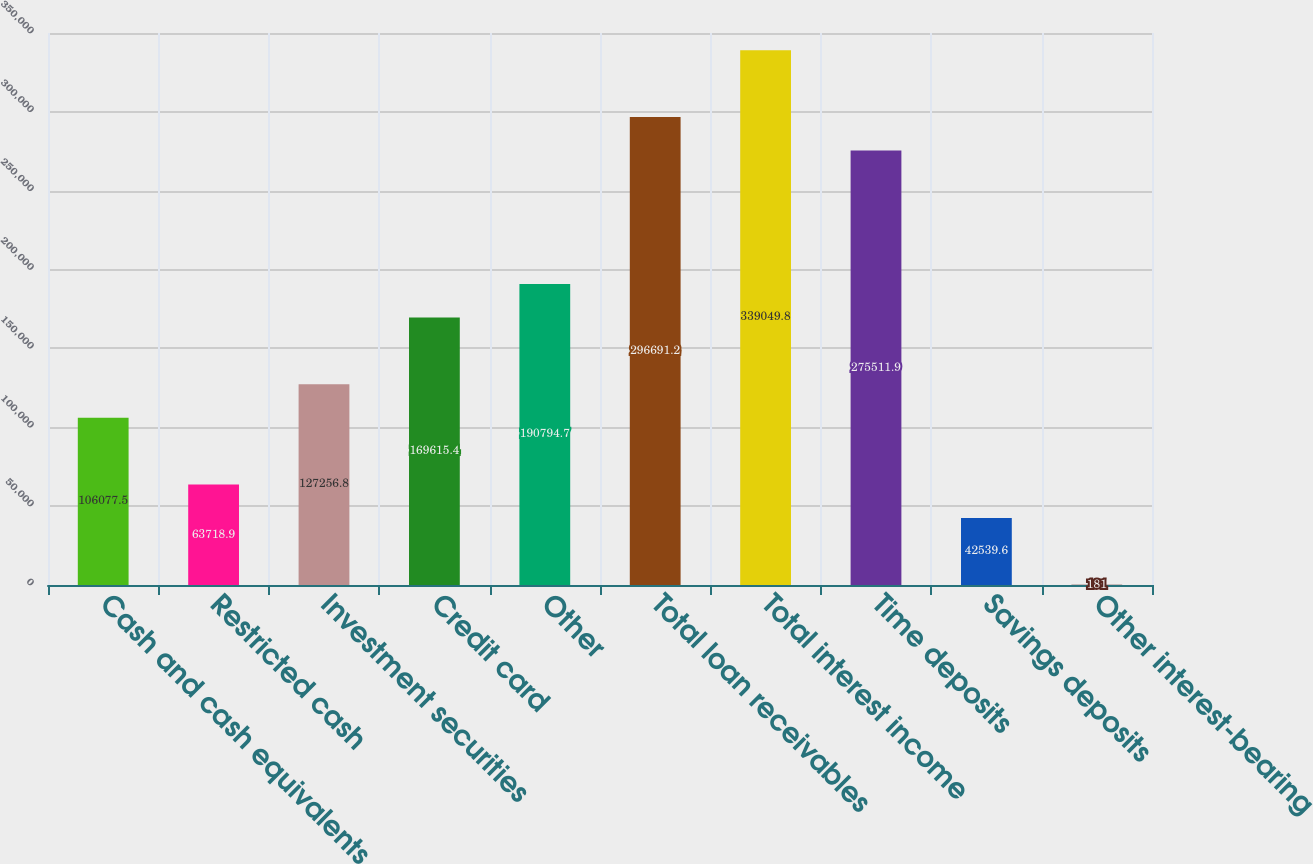Convert chart. <chart><loc_0><loc_0><loc_500><loc_500><bar_chart><fcel>Cash and cash equivalents<fcel>Restricted cash<fcel>Investment securities<fcel>Credit card<fcel>Other<fcel>Total loan receivables<fcel>Total interest income<fcel>Time deposits<fcel>Savings deposits<fcel>Other interest-bearing<nl><fcel>106078<fcel>63718.9<fcel>127257<fcel>169615<fcel>190795<fcel>296691<fcel>339050<fcel>275512<fcel>42539.6<fcel>181<nl></chart> 